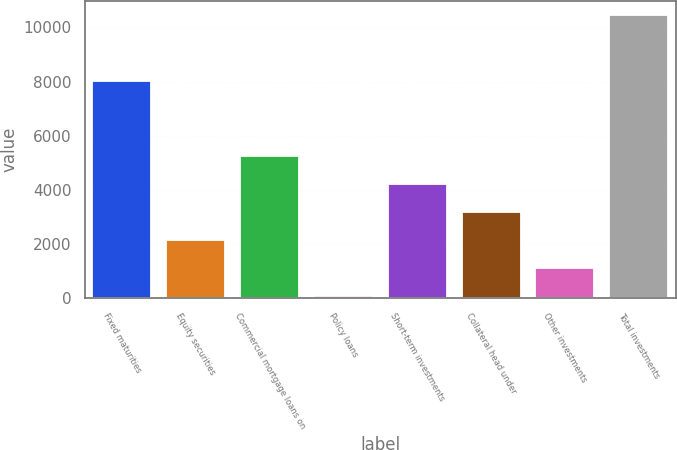Convert chart to OTSL. <chart><loc_0><loc_0><loc_500><loc_500><bar_chart><fcel>Fixed maturities<fcel>Equity securities<fcel>Commercial mortgage loans on<fcel>Policy loans<fcel>Short-term investments<fcel>Collateral head under<fcel>Other investments<fcel>Total investments<nl><fcel>8036<fcel>2147.4<fcel>5265<fcel>69<fcel>4225.8<fcel>3186.6<fcel>1108.2<fcel>10461<nl></chart> 